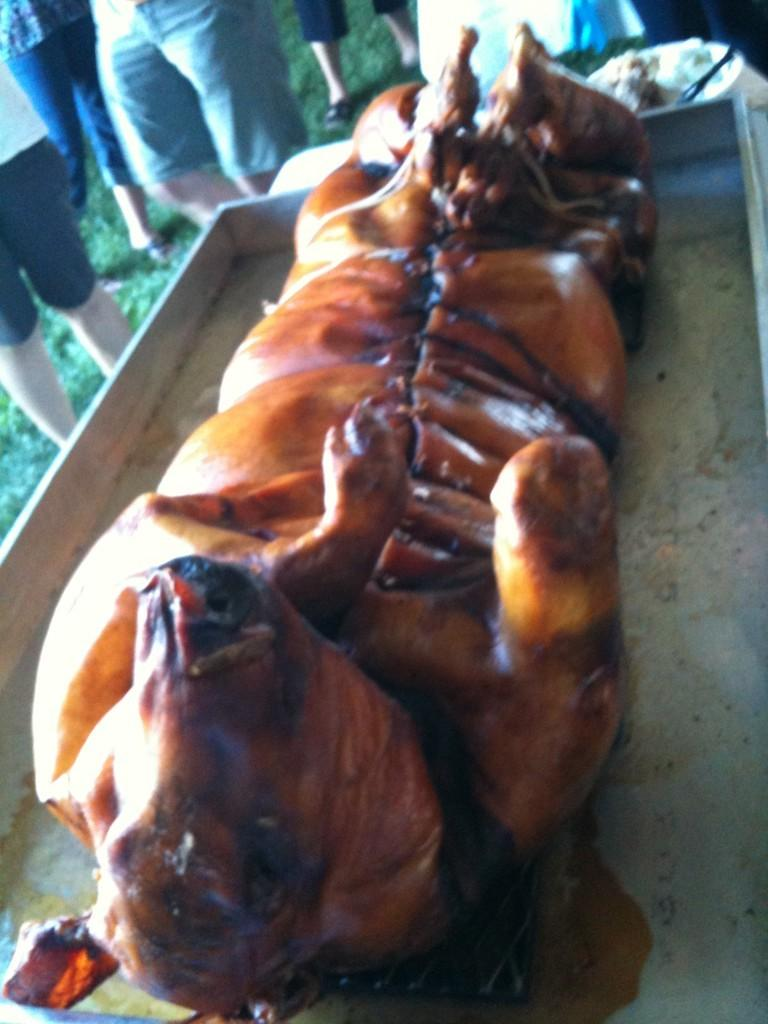What is the main subject of the image? The main subject of the image is a suckling pig on a metal plate. Where is the suckling pig located? The suckling pig is on a metal plate in the image. Are there any people visible in the image? Yes, there are a few persons standing on the grass in the top left side of the image. Can you see a receipt for the suckling pig in the image? There is no receipt visible in the image. What type of liquid is being served to the people in the image? There is no liquid being served in the image; the focus is on the suckling pig and the people standing nearby. 